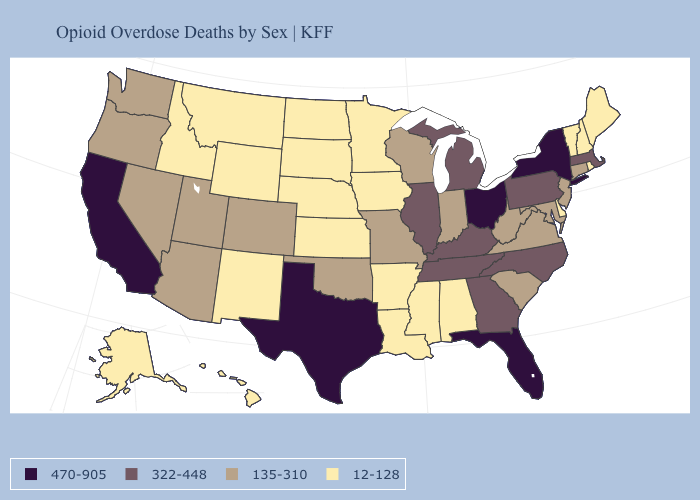Does New Hampshire have a higher value than Ohio?
Answer briefly. No. Name the states that have a value in the range 135-310?
Be succinct. Arizona, Colorado, Connecticut, Indiana, Maryland, Missouri, Nevada, New Jersey, Oklahoma, Oregon, South Carolina, Utah, Virginia, Washington, West Virginia, Wisconsin. Is the legend a continuous bar?
Answer briefly. No. Does Iowa have a lower value than Arizona?
Concise answer only. Yes. What is the highest value in the USA?
Give a very brief answer. 470-905. Name the states that have a value in the range 12-128?
Give a very brief answer. Alabama, Alaska, Arkansas, Delaware, Hawaii, Idaho, Iowa, Kansas, Louisiana, Maine, Minnesota, Mississippi, Montana, Nebraska, New Hampshire, New Mexico, North Dakota, Rhode Island, South Dakota, Vermont, Wyoming. Name the states that have a value in the range 12-128?
Give a very brief answer. Alabama, Alaska, Arkansas, Delaware, Hawaii, Idaho, Iowa, Kansas, Louisiana, Maine, Minnesota, Mississippi, Montana, Nebraska, New Hampshire, New Mexico, North Dakota, Rhode Island, South Dakota, Vermont, Wyoming. Does Alabama have a lower value than Maryland?
Give a very brief answer. Yes. Name the states that have a value in the range 322-448?
Short answer required. Georgia, Illinois, Kentucky, Massachusetts, Michigan, North Carolina, Pennsylvania, Tennessee. Does Maryland have the lowest value in the USA?
Keep it brief. No. What is the value of Utah?
Keep it brief. 135-310. What is the value of Tennessee?
Keep it brief. 322-448. Which states have the lowest value in the USA?
Answer briefly. Alabama, Alaska, Arkansas, Delaware, Hawaii, Idaho, Iowa, Kansas, Louisiana, Maine, Minnesota, Mississippi, Montana, Nebraska, New Hampshire, New Mexico, North Dakota, Rhode Island, South Dakota, Vermont, Wyoming. What is the value of New Jersey?
Short answer required. 135-310. Does the map have missing data?
Be succinct. No. 